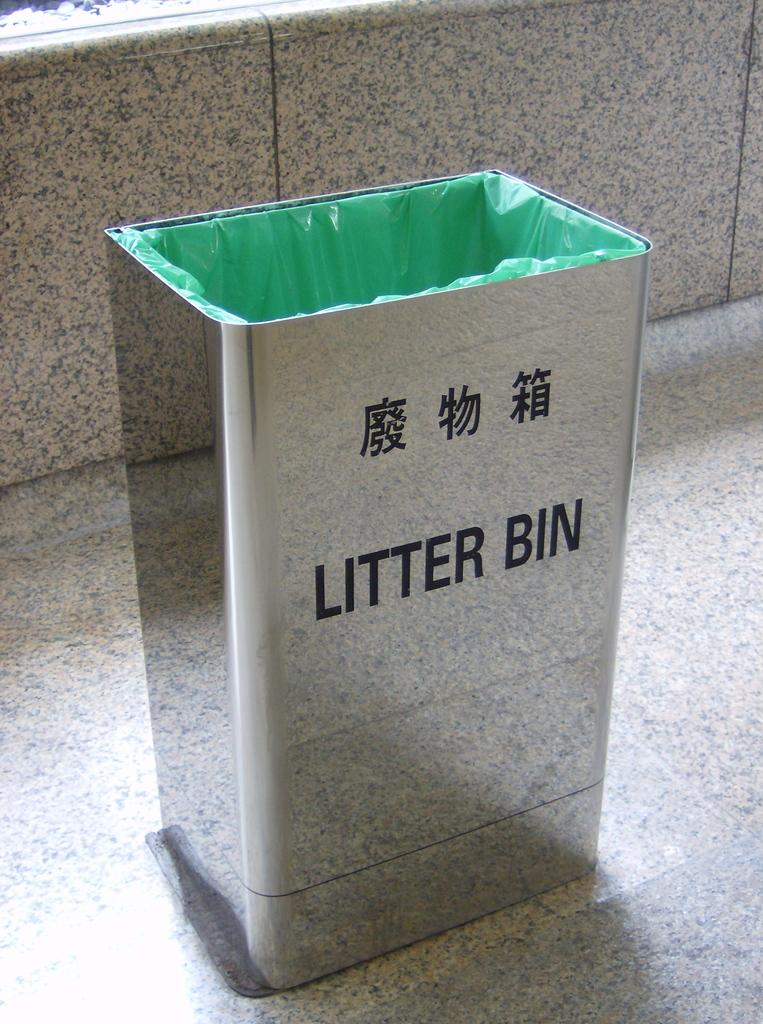<image>
Create a compact narrative representing the image presented. A silver colored littler bin has a green bag inside of it. 